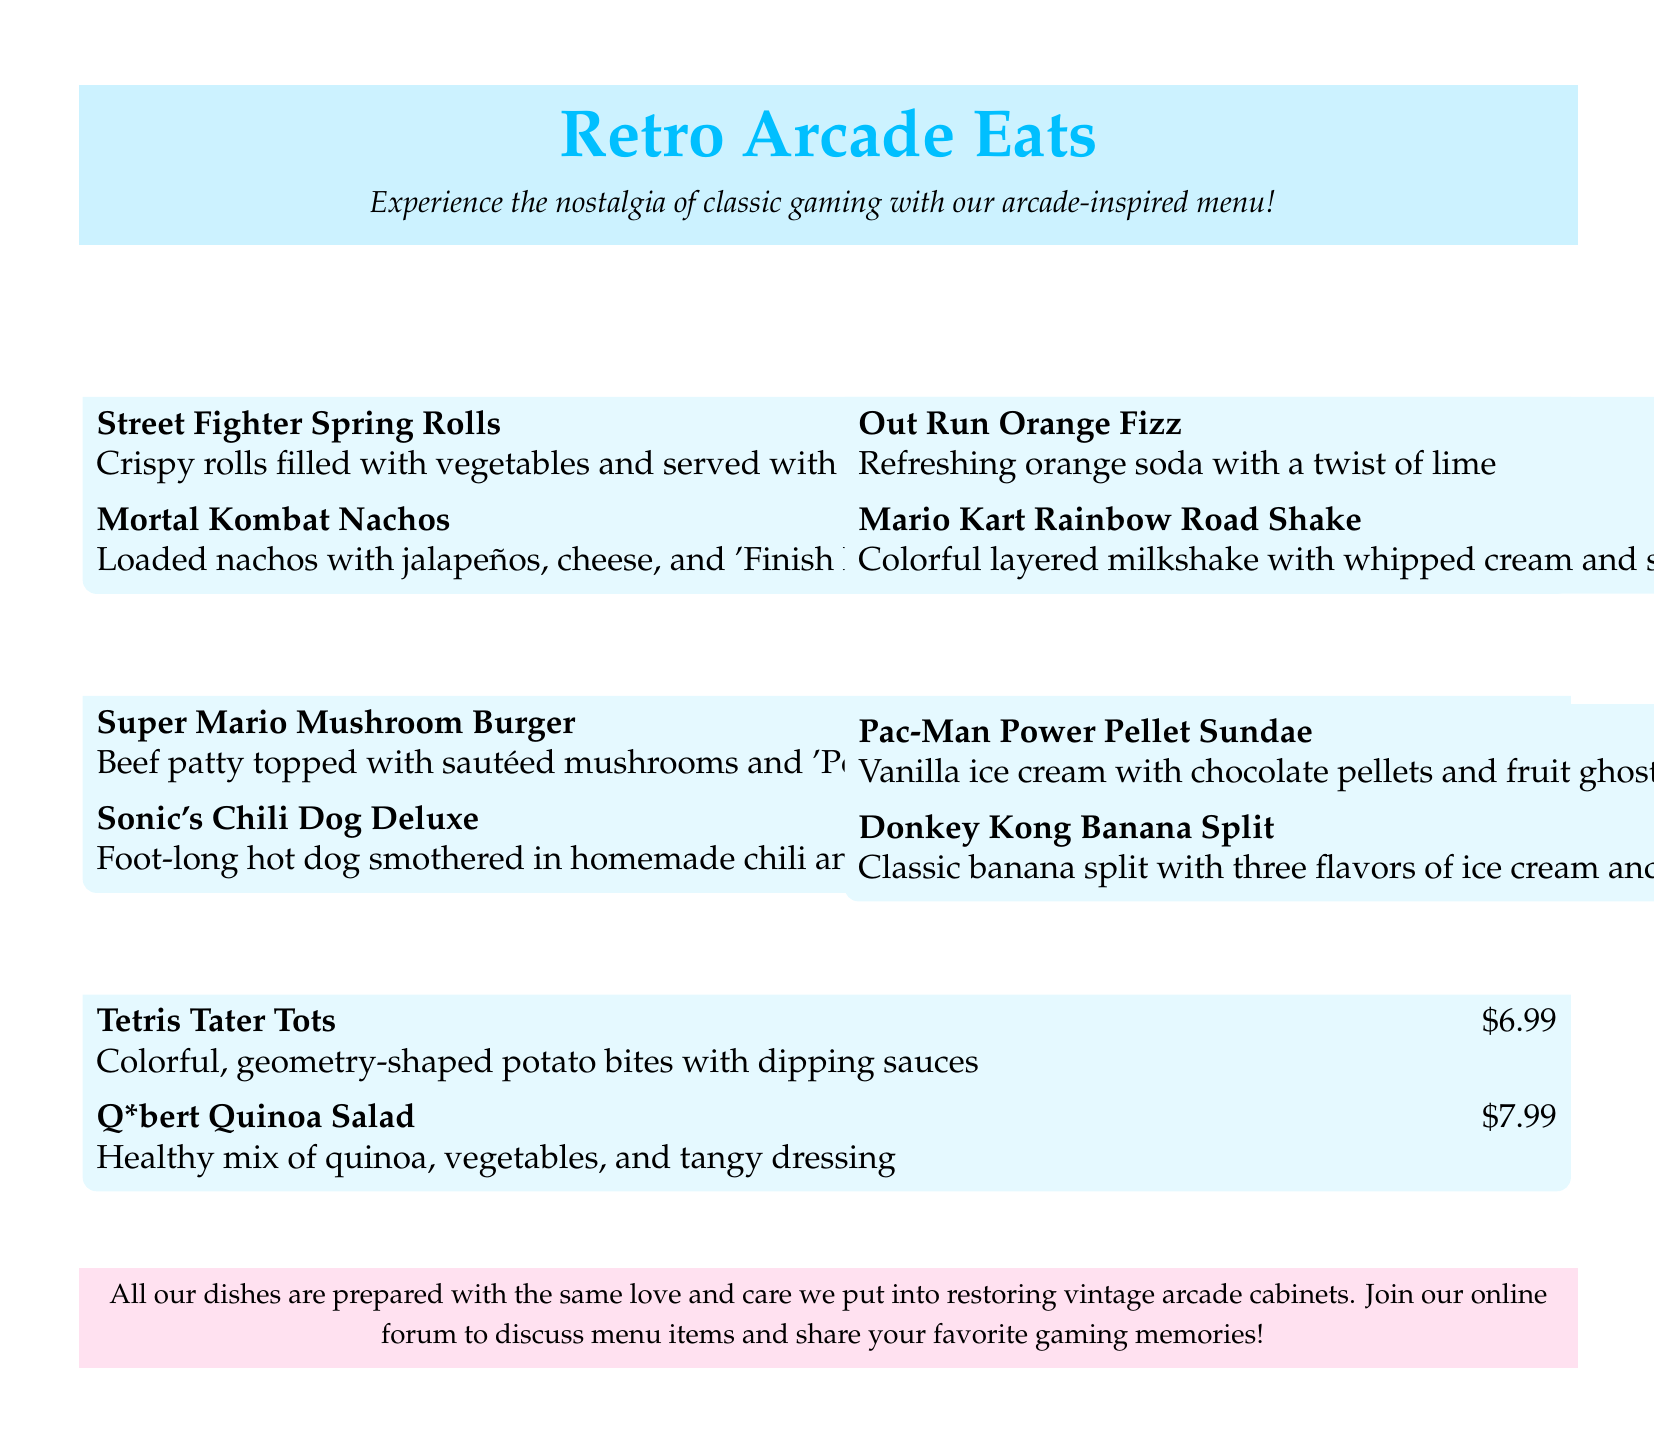What is the title of the menu? The title is prominently displayed at the top of the document, reading Retro Arcade Eats.
Answer: Retro Arcade Eats How much are the Mortal Kombat Nachos? The price for the Mortal Kombat Nachos is listed beside the item description.
Answer: $10.99 What type of drink is the Mario Kart Rainbow Road Shake? The drink type is indicated in the drinks section of the menu, specifically mentioned as a shake.
Answer: Shake Which appetizer features a hot sauce? The description for Street Fighter Spring Rolls mentions serving them with Hadouken hot sauce.
Answer: Street Fighter Spring Rolls What is the main ingredient in the Super Mario Mushroom Burger? The item description specifies that the main ingredient is a beef patty.
Answer: Beef patty What genre does the Q*bert Quinoa Salad belong to? The genre is labeled in the sides section of the menu, where it is categorized under Puzzle Game Sides.
Answer: Puzzle Game Sides How much is the Pac-Man Power Pellet Sundae? The price for the Pac-Man Power Pellet Sundae is listed next to the dessert name.
Answer: $7.99 What inspired the menu's design? The menu notes that it is inspired by the nostalgia of classic gaming.
Answer: Classic gaming How should customers engage with the restaurant after their meal? The document suggests joining an online forum for discussions about menu items.
Answer: Join our online forum 